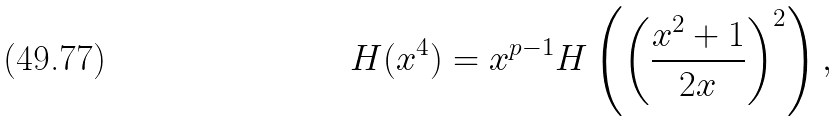<formula> <loc_0><loc_0><loc_500><loc_500>H ( x ^ { 4 } ) = x ^ { p - 1 } H \left ( \left ( \frac { x ^ { 2 } + 1 } { 2 x } \right ) ^ { 2 } \right ) ,</formula> 